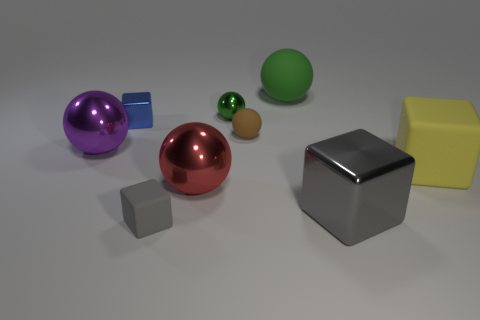What shape is the small object that is in front of the big object left of the small cube in front of the purple metal thing?
Provide a succinct answer. Cube. How many balls are either purple things or small green objects?
Provide a short and direct response. 2. There is a gray block to the left of the small green object; are there any red metal things that are on the right side of it?
Provide a succinct answer. Yes. There is a green metallic thing; does it have the same shape as the big metallic object that is behind the large yellow matte thing?
Ensure brevity in your answer.  Yes. What number of other things are there of the same size as the purple shiny ball?
Give a very brief answer. 4. How many brown things are tiny spheres or big matte spheres?
Offer a very short reply. 1. What number of balls are on the left side of the tiny brown sphere and behind the purple thing?
Provide a succinct answer. 1. What is the material of the gray object to the right of the green sphere that is on the left side of the matte ball that is in front of the green rubber thing?
Your answer should be compact. Metal. What number of big gray blocks have the same material as the tiny blue cube?
Offer a terse response. 1. The matte object that is the same color as the large metallic block is what shape?
Your answer should be very brief. Cube. 